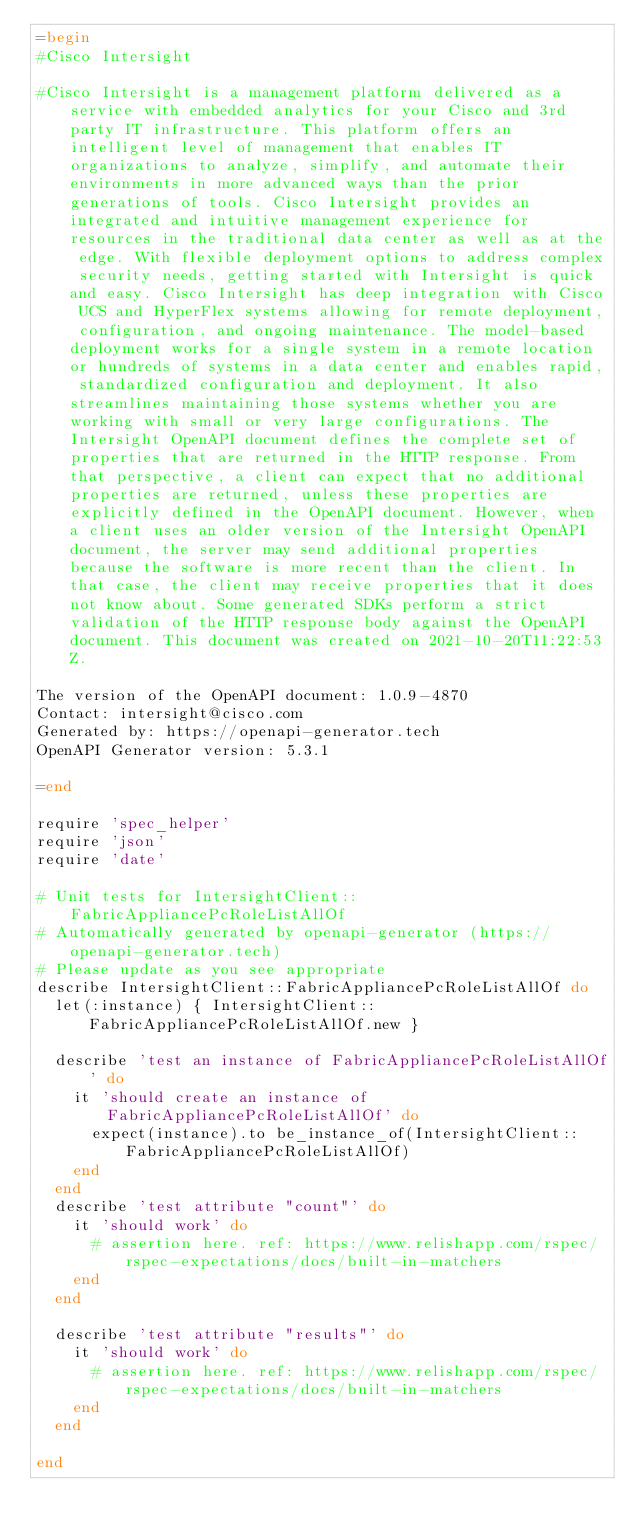<code> <loc_0><loc_0><loc_500><loc_500><_Ruby_>=begin
#Cisco Intersight

#Cisco Intersight is a management platform delivered as a service with embedded analytics for your Cisco and 3rd party IT infrastructure. This platform offers an intelligent level of management that enables IT organizations to analyze, simplify, and automate their environments in more advanced ways than the prior generations of tools. Cisco Intersight provides an integrated and intuitive management experience for resources in the traditional data center as well as at the edge. With flexible deployment options to address complex security needs, getting started with Intersight is quick and easy. Cisco Intersight has deep integration with Cisco UCS and HyperFlex systems allowing for remote deployment, configuration, and ongoing maintenance. The model-based deployment works for a single system in a remote location or hundreds of systems in a data center and enables rapid, standardized configuration and deployment. It also streamlines maintaining those systems whether you are working with small or very large configurations. The Intersight OpenAPI document defines the complete set of properties that are returned in the HTTP response. From that perspective, a client can expect that no additional properties are returned, unless these properties are explicitly defined in the OpenAPI document. However, when a client uses an older version of the Intersight OpenAPI document, the server may send additional properties because the software is more recent than the client. In that case, the client may receive properties that it does not know about. Some generated SDKs perform a strict validation of the HTTP response body against the OpenAPI document. This document was created on 2021-10-20T11:22:53Z.

The version of the OpenAPI document: 1.0.9-4870
Contact: intersight@cisco.com
Generated by: https://openapi-generator.tech
OpenAPI Generator version: 5.3.1

=end

require 'spec_helper'
require 'json'
require 'date'

# Unit tests for IntersightClient::FabricAppliancePcRoleListAllOf
# Automatically generated by openapi-generator (https://openapi-generator.tech)
# Please update as you see appropriate
describe IntersightClient::FabricAppliancePcRoleListAllOf do
  let(:instance) { IntersightClient::FabricAppliancePcRoleListAllOf.new }

  describe 'test an instance of FabricAppliancePcRoleListAllOf' do
    it 'should create an instance of FabricAppliancePcRoleListAllOf' do
      expect(instance).to be_instance_of(IntersightClient::FabricAppliancePcRoleListAllOf)
    end
  end
  describe 'test attribute "count"' do
    it 'should work' do
      # assertion here. ref: https://www.relishapp.com/rspec/rspec-expectations/docs/built-in-matchers
    end
  end

  describe 'test attribute "results"' do
    it 'should work' do
      # assertion here. ref: https://www.relishapp.com/rspec/rspec-expectations/docs/built-in-matchers
    end
  end

end
</code> 